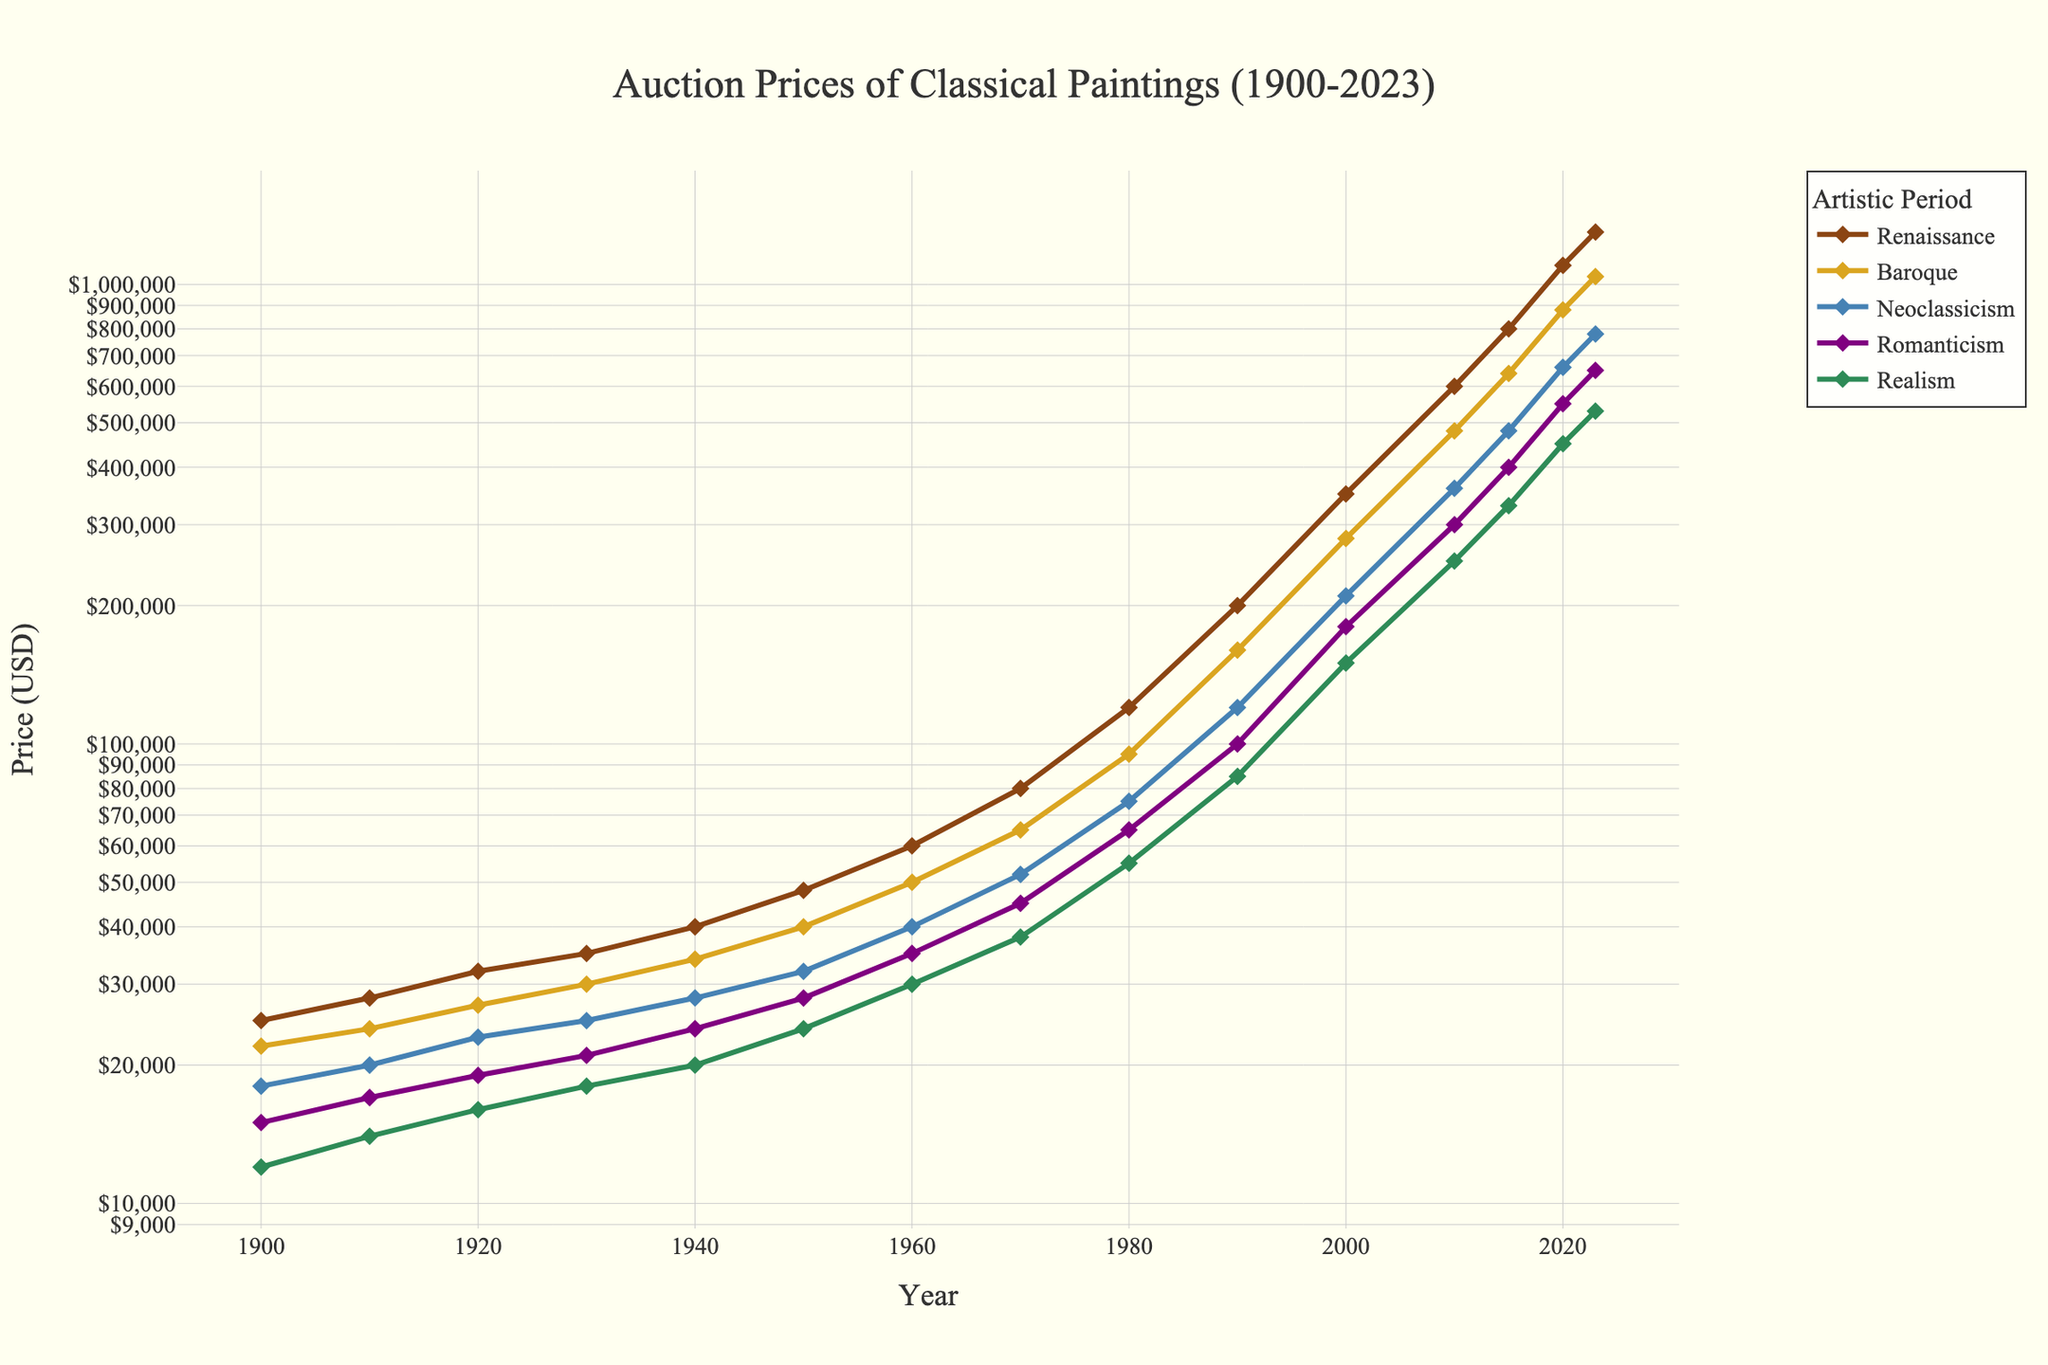What is the price difference of Renaissance paintings between 2020 and 2023? Find the price of Renaissance paintings in 2020 ($1,100,000) and the price in 2023 ($1,300,000). Subtract to get the difference: $1,300,000 - $1,100,000.
Answer: $200,000 Which artistic period had the lowest auction price in 1900? Look at the prices for all periods in 1900 and identify the lowest value: Renaissance ($25,000), Baroque ($22,000), Neoclassicism ($18,000), Romanticism ($15,000), Realism ($12,000).
Answer: Realism By how much did the auction price of Romanticism paintings increase from 1950 to 2000? Find the price of Romanticism paintings in 1950 ($28,000) and in 2000 ($180,000). Subtract the values: $180,000 - $28,000.
Answer: $152,000 Which artistic period showed the highest percentage increase in auction price from 2000 to 2023? Calculate the price increase for each period from 2000 to 2023, then find the percentage increase: Renaissance (1,300,000-350,000)/350,000 = 271.43%, Baroque (1,040,000-280,000)/280,000 = 271.43%, Neoclassicism (780,000-210,000)/210,000 = 271.43%, Romanticism (650,000-180,000)/180,000 = 261.11%, Realism (530,000-150,000)/150,000 = 253.33%.
Answer: Renaissance, Baroque, Neoclassicism What is the average auction price of Neoclassicism paintings from 1900 to 1920? Find the prices of Neoclassicism in 1900 ($18,000), 1910 ($20,000), and 1920 ($23,000) and average them: (18,000 + 20,000 + 23,000) / 3.
Answer: $20,333.33 Which artistic period had the smallest price increase between 2015 and 2023? Calculate the increase for each period from 2015 to 2023: Renaissance ($1,300,000 - $800,000), Baroque ($1,040,000 - $640,000), Neoclassicism ($780,000 - $480,000), Romanticism ($650,000 - $400,000), Realism ($530,000 - $330,000). Compare the differences.
Answer: Realism What color represents the Renaissance artistic period in the plot? Identify the line representing Renaissance using the legend or the color-coded lines in the plot.
Answer: Brown Between which consecutive years did the auction prices of Baroque paintings show the largest absolute increase? Calculate the absolute increase between every consecutive pair of years for Baroque: 1900-1910, 1910-1920, ..., 2020-2023. Identify the largest increase.
Answer: 2010-2015 